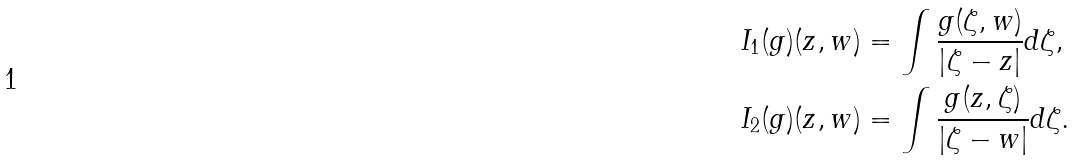Convert formula to latex. <formula><loc_0><loc_0><loc_500><loc_500>I _ { 1 } ( g ) ( z , w ) & = \int \frac { g ( \zeta , w ) } { \left | \zeta - z \right | } d \zeta , \\ I _ { 2 } ( g ) ( z , w ) & = \int \frac { g ( z , \zeta ) } { \left | \zeta - w \right | } d \zeta .</formula> 